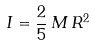<formula> <loc_0><loc_0><loc_500><loc_500>I = \frac { 2 } { 5 } \, M \, R ^ { 2 }</formula> 